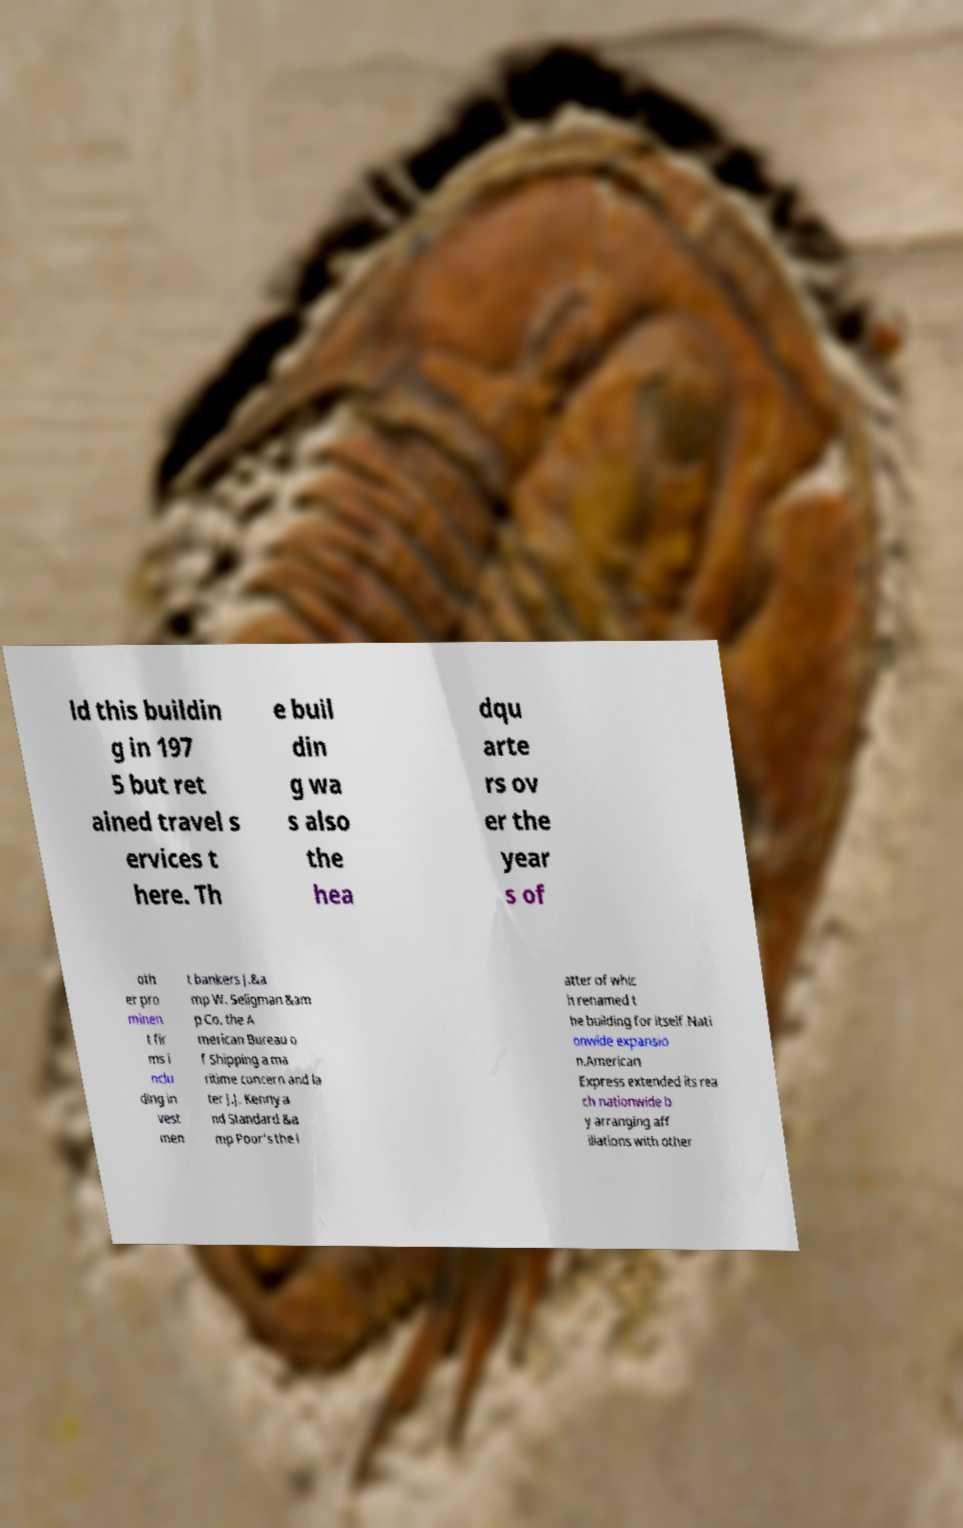Can you read and provide the text displayed in the image?This photo seems to have some interesting text. Can you extract and type it out for me? ld this buildin g in 197 5 but ret ained travel s ervices t here. Th e buil din g wa s also the hea dqu arte rs ov er the year s of oth er pro minen t fir ms i nclu ding in vest men t bankers J.&a mp W. Seligman &am p Co. the A merican Bureau o f Shipping a ma ritime concern and la ter J.J. Kenny a nd Standard &a mp Poor's the l atter of whic h renamed t he building for itself.Nati onwide expansio n.American Express extended its rea ch nationwide b y arranging aff iliations with other 